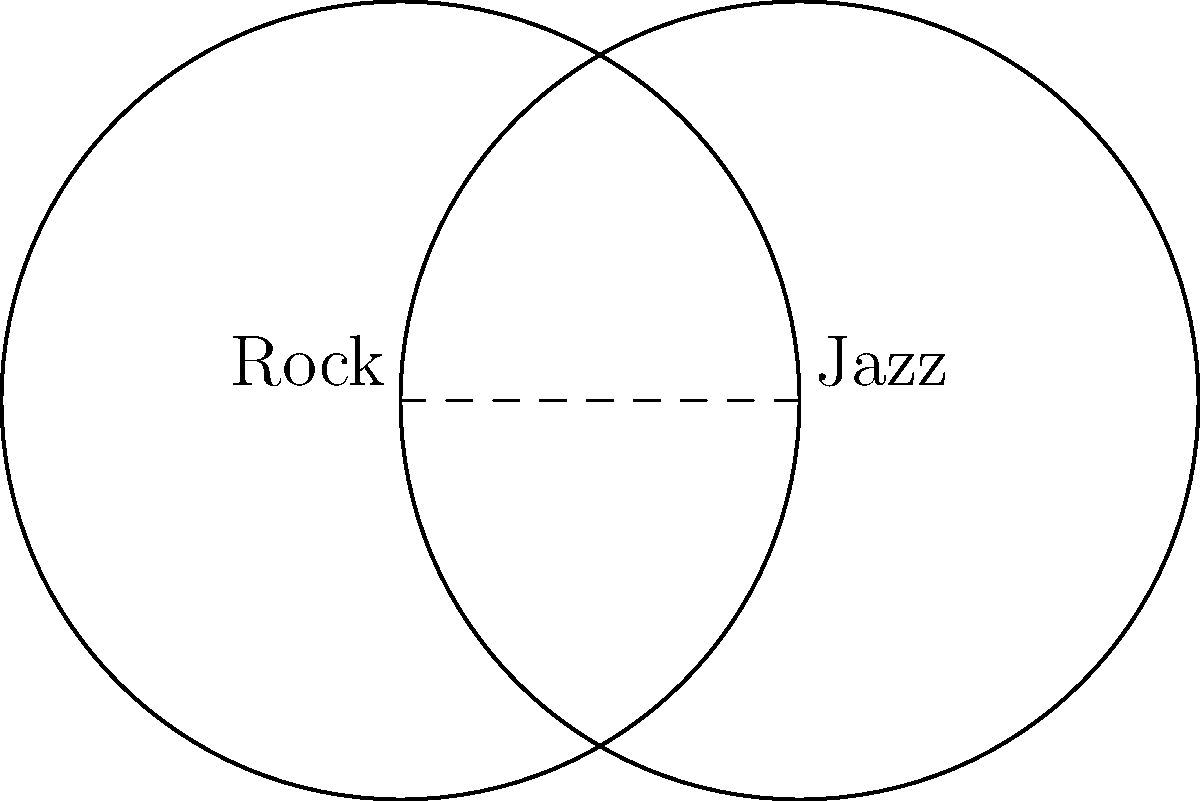In a music genre popularity analysis, two intersecting circles represent the fan bases of Rock and Jazz. Each circle has a radius of 1.5 units, and their centers are 1.5 units apart. Calculate the area of the overlapping region, representing fans who enjoy both genres. Round your answer to two decimal places. To find the area of overlap between two intersecting circles, we can follow these steps:

1) First, we need to find the angle $\theta$ at the center of each circle that forms the overlap:
   $\cos(\frac{\theta}{2}) = \frac{d}{2r}$, where $d$ is the distance between centers and $r$ is the radius.
   
   $\cos(\frac{\theta}{2}) = \frac{1.5}{2(1.5)} = 0.5$
   
   $\frac{\theta}{2} = \arccos(0.5) = \frac{\pi}{3}$
   
   $\theta = \frac{2\pi}{3}$

2) The area of the circular sector formed in each circle is:
   $A_{sector} = \frac{1}{2}r^2\theta = \frac{1}{2}(1.5)^2 \cdot \frac{2\pi}{3} = \frac{\pi}{2}$

3) The area of the triangle formed in each circle is:
   $A_{triangle} = \frac{1}{2}r^2\sin(\theta) = \frac{1}{2}(1.5)^2 \cdot \frac{\sqrt{3}}{2} = \frac{9\sqrt{3}}{8}$

4) The area of overlap for each circle is the difference between the sector and triangle:
   $A_{overlap} = A_{sector} - A_{triangle} = \frac{\pi}{2} - \frac{9\sqrt{3}}{8}$

5) The total area of overlap is twice this amount:
   $A_{total} = 2(\frac{\pi}{2} - \frac{9\sqrt{3}}{8}) = \pi - \frac{9\sqrt{3}}{4} \approx 0.5748$ square units

Rounding to two decimal places gives 0.57 square units.
Answer: 0.57 square units 